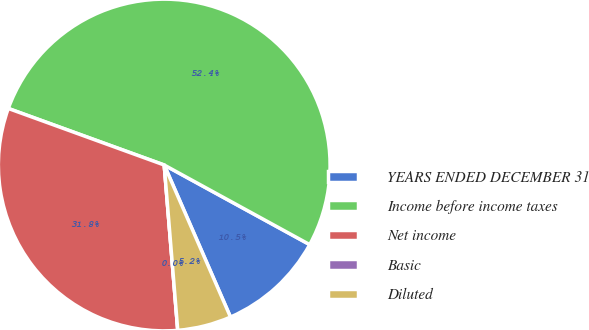Convert chart. <chart><loc_0><loc_0><loc_500><loc_500><pie_chart><fcel>YEARS ENDED DECEMBER 31<fcel>Income before income taxes<fcel>Net income<fcel>Basic<fcel>Diluted<nl><fcel>10.49%<fcel>52.43%<fcel>31.84%<fcel>0.0%<fcel>5.24%<nl></chart> 